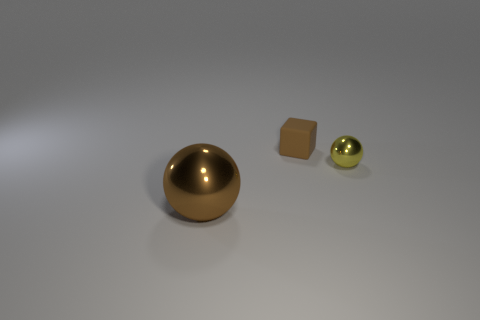Is the number of brown metallic balls behind the small sphere less than the number of tiny yellow rubber objects?
Your answer should be very brief. No. There is a metal ball that is the same color as the cube; what size is it?
Give a very brief answer. Large. Is there any other thing that has the same size as the yellow sphere?
Provide a succinct answer. Yes. Is the yellow sphere made of the same material as the big brown sphere?
Give a very brief answer. Yes. How many objects are tiny yellow spheres that are on the right side of the big brown metallic object or metal balls that are behind the brown sphere?
Provide a succinct answer. 1. Is there another brown cube of the same size as the cube?
Offer a very short reply. No. What is the color of the large object that is the same shape as the small metal thing?
Provide a succinct answer. Brown. There is a brown sphere in front of the small metallic object; are there any brown spheres that are on the right side of it?
Your answer should be compact. No. Is the shape of the thing behind the small metal thing the same as  the small shiny object?
Give a very brief answer. No. The tiny yellow object is what shape?
Your response must be concise. Sphere. 